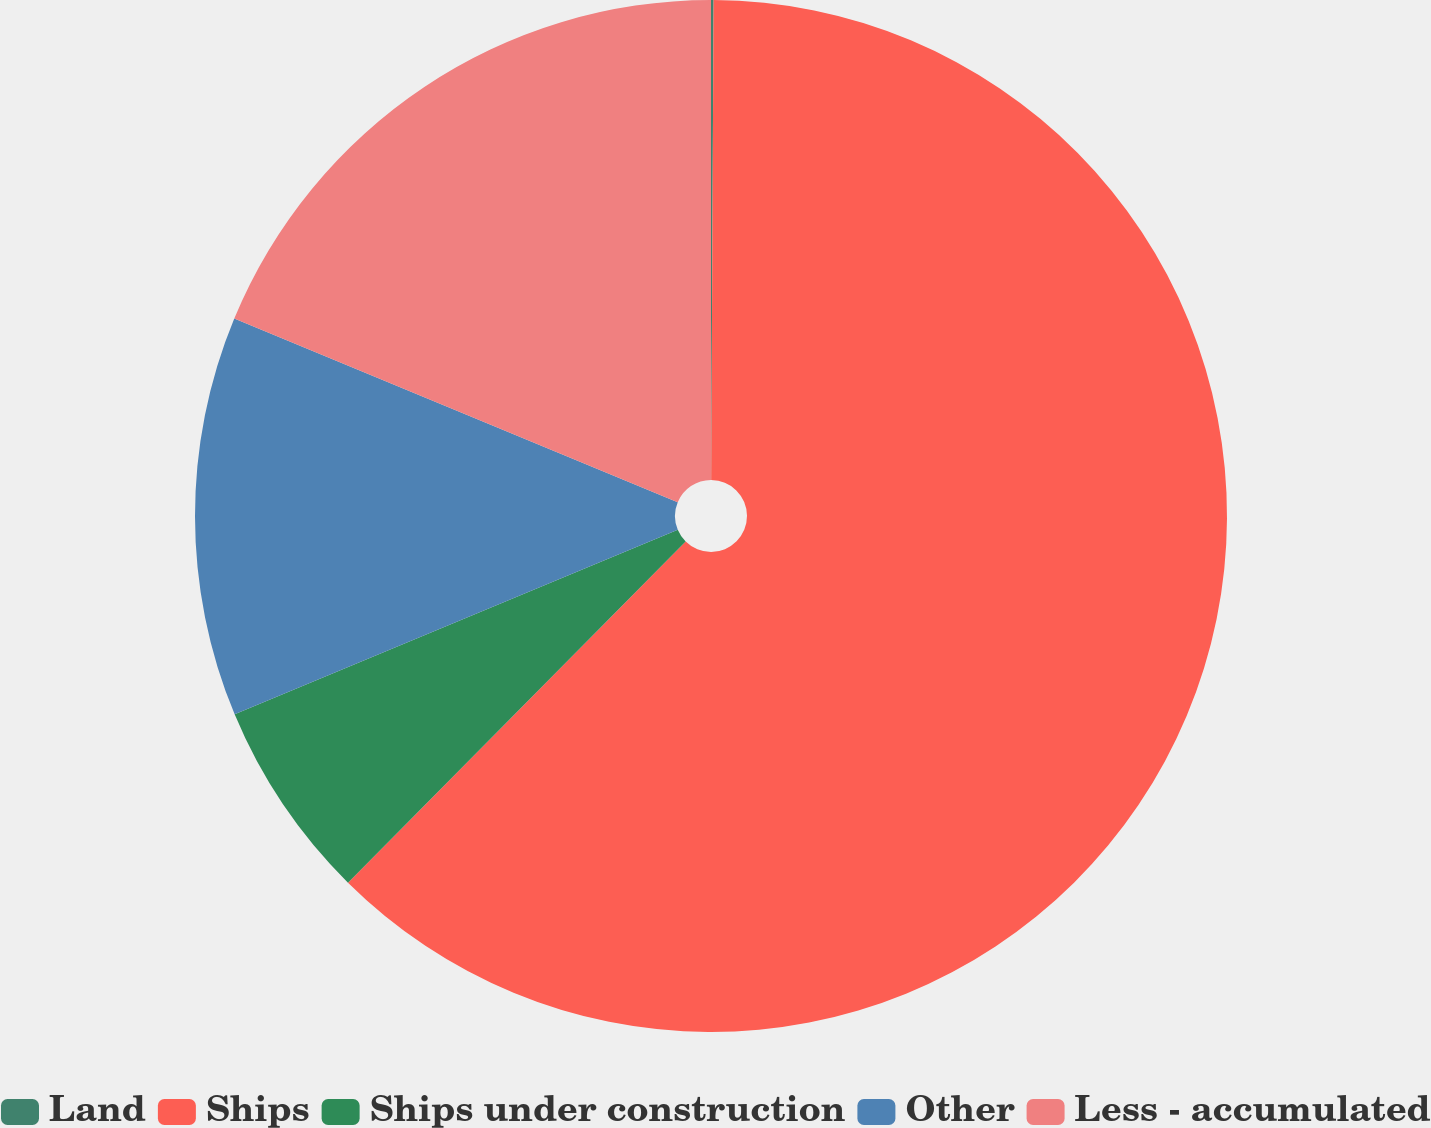Convert chart to OTSL. <chart><loc_0><loc_0><loc_500><loc_500><pie_chart><fcel>Land<fcel>Ships<fcel>Ships under construction<fcel>Other<fcel>Less - accumulated<nl><fcel>0.08%<fcel>62.34%<fcel>6.3%<fcel>12.53%<fcel>18.75%<nl></chart> 